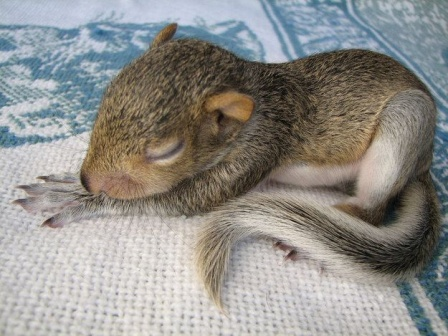Can you describe the blanket in the image? Certainly! The blanket in the image features an intricate geometric pattern composed of blue and white hues. The design consists of various shapes and lines that form a visually appealing and cohesive arrangement. The texture of the blanket appears to be soft and woven, providing a comfortable surface for the baby squirrel to rest on. This detailed craftsmanship and color scheme add to the overall serene and cozy atmosphere of the image. 